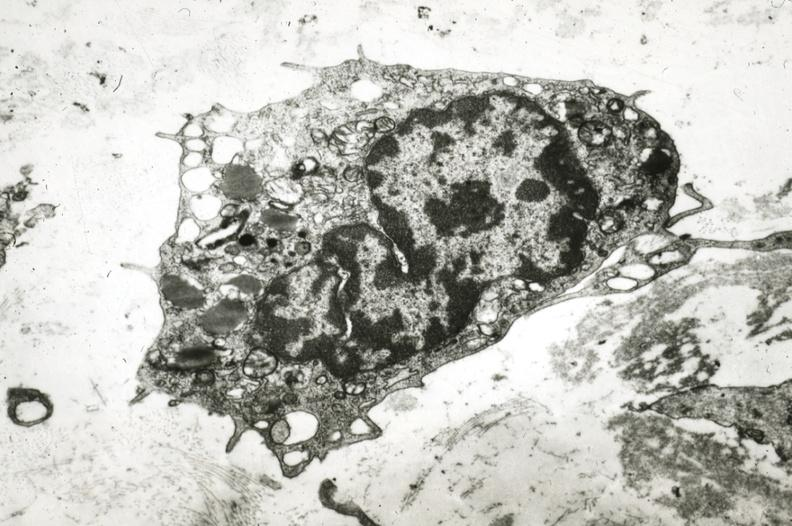what is present?
Answer the question using a single word or phrase. Vasculature 